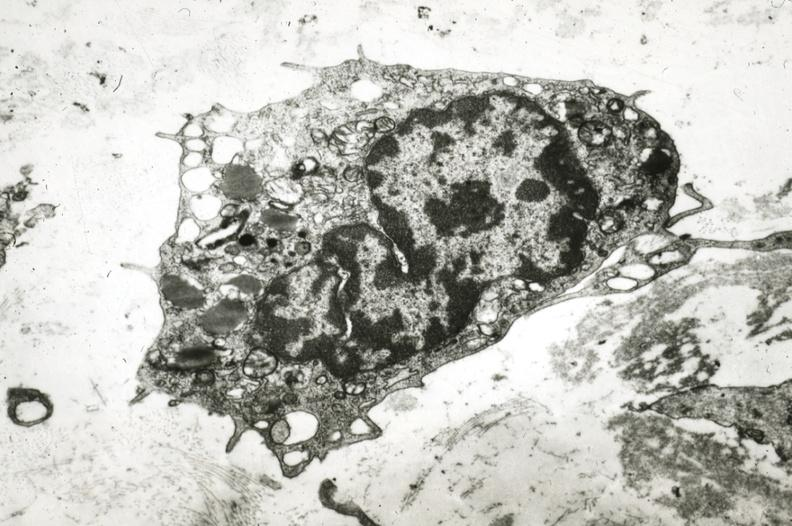what is present?
Answer the question using a single word or phrase. Vasculature 